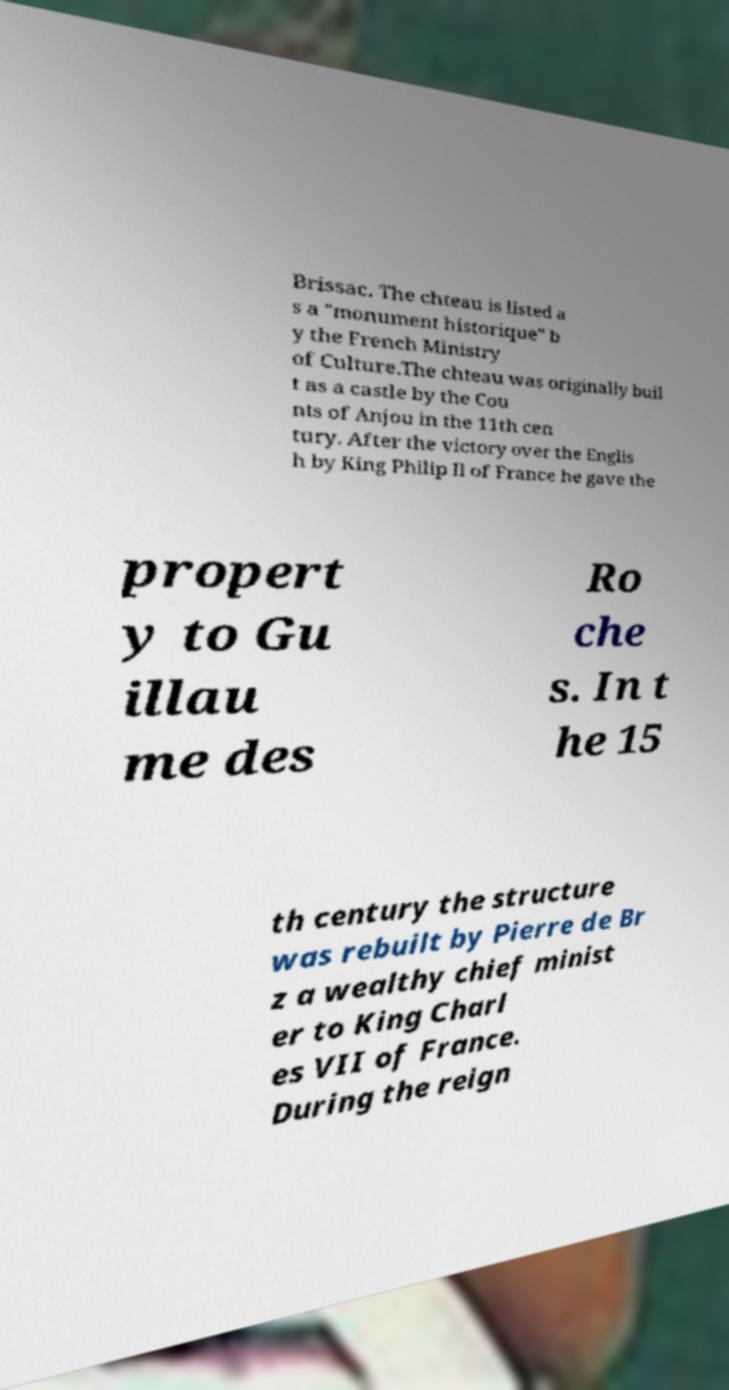For documentation purposes, I need the text within this image transcribed. Could you provide that? Brissac. The chteau is listed a s a "monument historique" b y the French Ministry of Culture.The chteau was originally buil t as a castle by the Cou nts of Anjou in the 11th cen tury. After the victory over the Englis h by King Philip II of France he gave the propert y to Gu illau me des Ro che s. In t he 15 th century the structure was rebuilt by Pierre de Br z a wealthy chief minist er to King Charl es VII of France. During the reign 